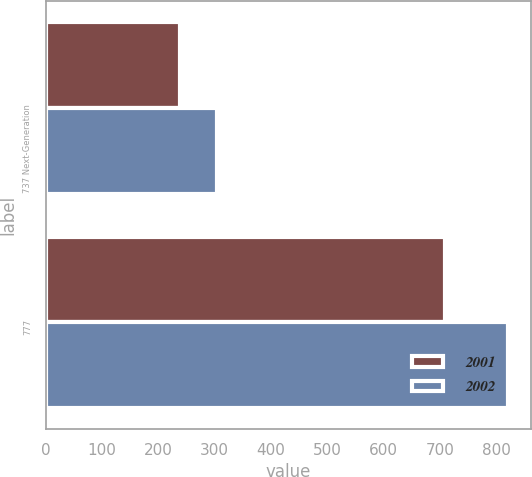Convert chart. <chart><loc_0><loc_0><loc_500><loc_500><stacked_bar_chart><ecel><fcel>737 Next-Generation<fcel>777<nl><fcel>2001<fcel>239<fcel>709<nl><fcel>2002<fcel>305<fcel>821<nl></chart> 